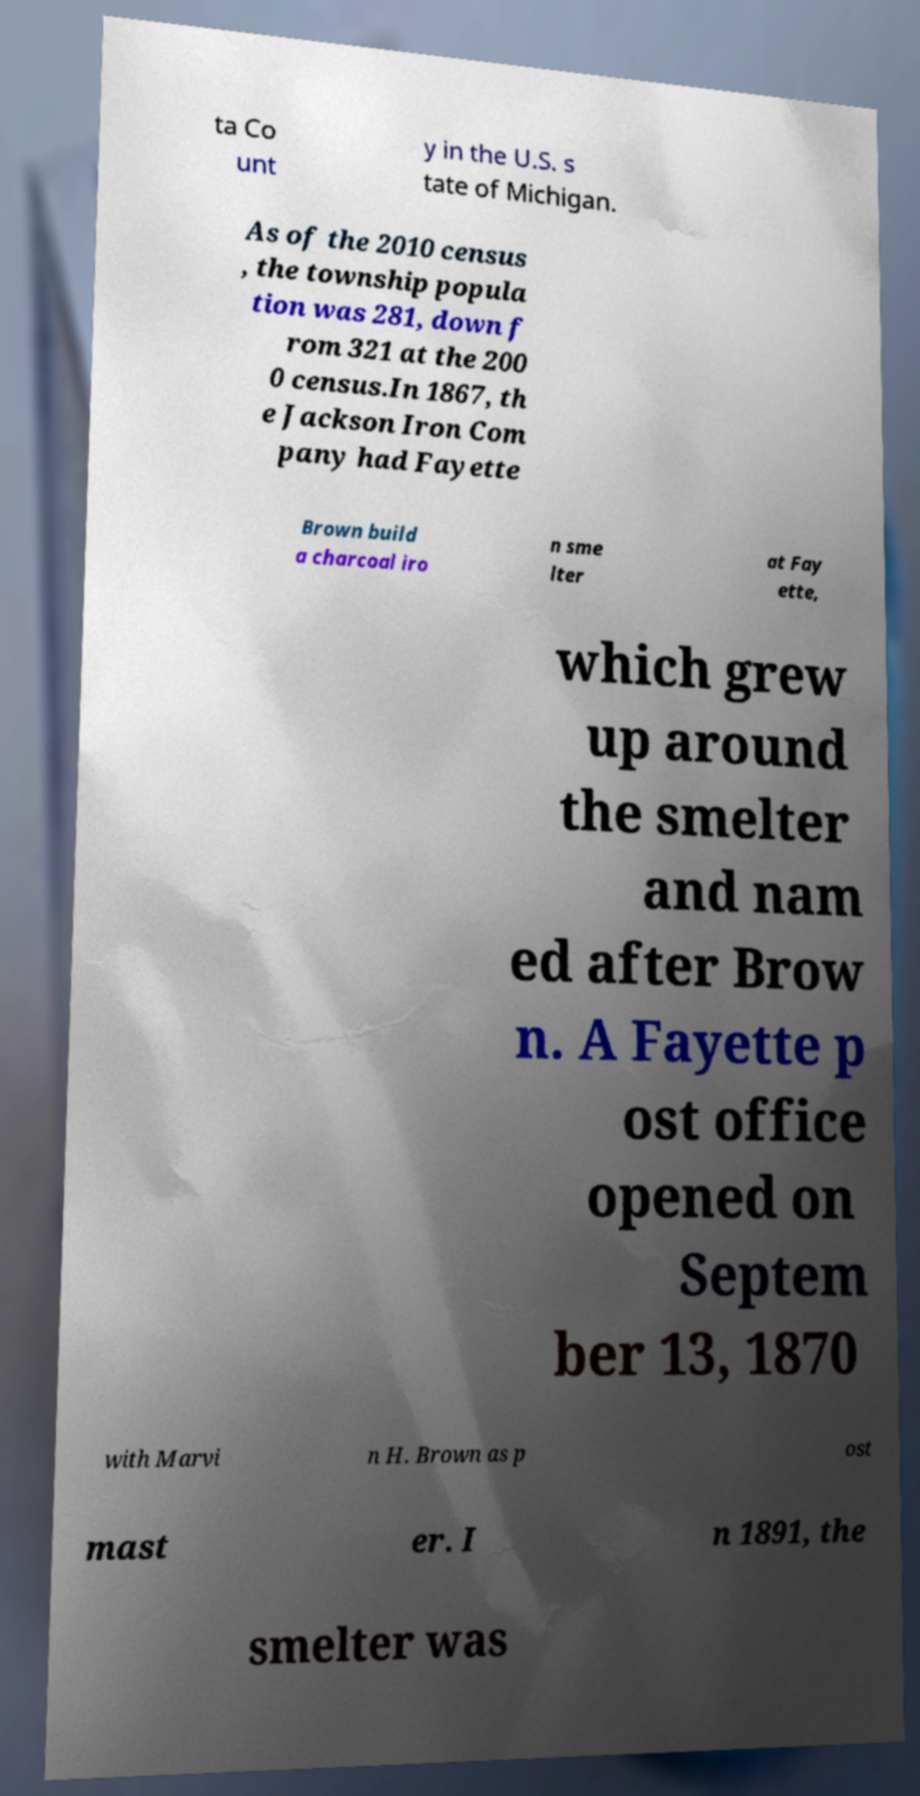There's text embedded in this image that I need extracted. Can you transcribe it verbatim? ta Co unt y in the U.S. s tate of Michigan. As of the 2010 census , the township popula tion was 281, down f rom 321 at the 200 0 census.In 1867, th e Jackson Iron Com pany had Fayette Brown build a charcoal iro n sme lter at Fay ette, which grew up around the smelter and nam ed after Brow n. A Fayette p ost office opened on Septem ber 13, 1870 with Marvi n H. Brown as p ost mast er. I n 1891, the smelter was 